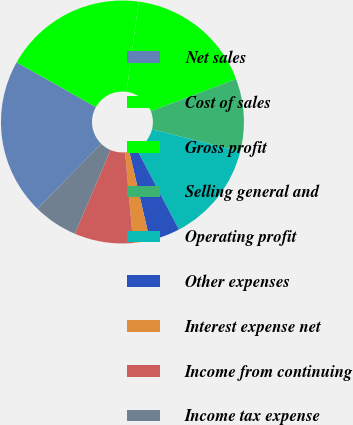Convert chart. <chart><loc_0><loc_0><loc_500><loc_500><pie_chart><fcel>Net sales<fcel>Cost of sales<fcel>Gross profit<fcel>Selling general and<fcel>Operating profit<fcel>Other expenses<fcel>Interest expense net<fcel>Income from continuing<fcel>Income tax expense<nl><fcel>20.83%<fcel>18.97%<fcel>17.11%<fcel>9.66%<fcel>13.39%<fcel>4.08%<fcel>2.22%<fcel>7.8%<fcel>5.94%<nl></chart> 